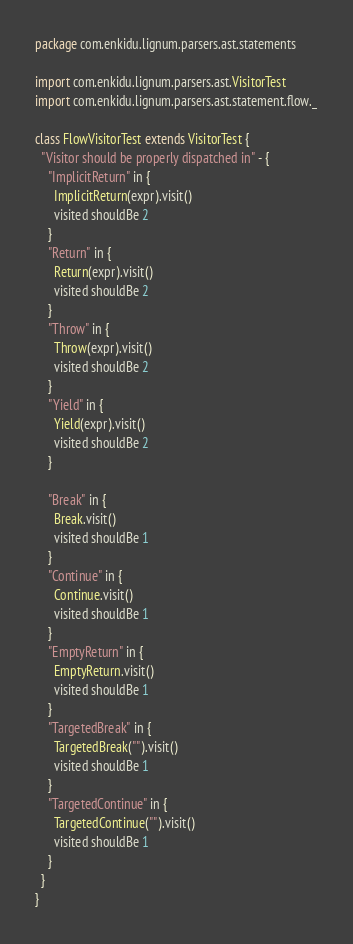Convert code to text. <code><loc_0><loc_0><loc_500><loc_500><_Scala_>package com.enkidu.lignum.parsers.ast.statements

import com.enkidu.lignum.parsers.ast.VisitorTest
import com.enkidu.lignum.parsers.ast.statement.flow._

class FlowVisitorTest extends VisitorTest {
  "Visitor should be properly dispatched in" - {
    "ImplicitReturn" in {
      ImplicitReturn(expr).visit()
      visited shouldBe 2
    }
    "Return" in {
      Return(expr).visit()
      visited shouldBe 2
    }
    "Throw" in {
      Throw(expr).visit()
      visited shouldBe 2
    }
    "Yield" in {
      Yield(expr).visit()
      visited shouldBe 2
    }

    "Break" in {
      Break.visit()
      visited shouldBe 1
    }
    "Continue" in {
      Continue.visit()
      visited shouldBe 1
    }
    "EmptyReturn" in {
      EmptyReturn.visit()
      visited shouldBe 1
    }
    "TargetedBreak" in {
      TargetedBreak("").visit()
      visited shouldBe 1
    }
    "TargetedContinue" in {
      TargetedContinue("").visit()
      visited shouldBe 1
    }
  }
}
</code> 